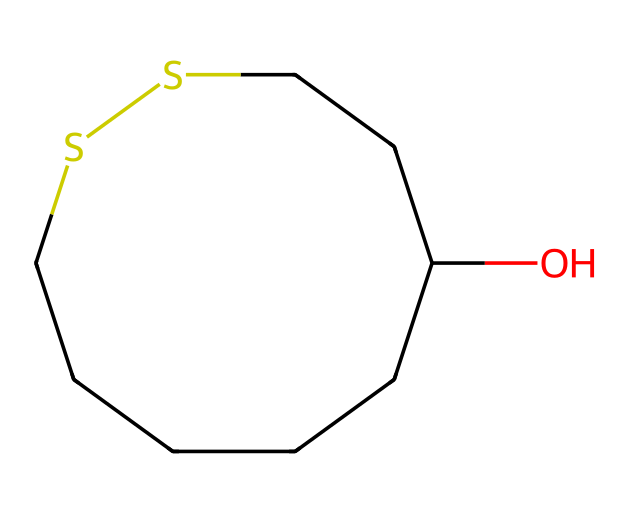How many carbon atoms are present in alpha-lipoic acid? By examining the SMILES structure, we can count the number of 'C' characters, representing carbon atoms. In this structure, there are six 'C' characters, indicating six carbon atoms.
Answer: six What type of functional group is represented by the "OC" portion of the SMILES? The "OC" indicates a hydroxy (alcohol) group, where "O" represents the oxygen atom and "C" is connected to it. This suggests the presence of an alcohol functional group in the compound.
Answer: hydroxy How many sulfur atoms are in the structure? The presence of 'S' in the SMILES indicates sulfur atoms. By counting the 'S' characters in the structure, we find there are two 'S' characters, meaning there are two sulfur atoms.
Answer: two Is alpha-lipoic acid a cyclic compound? The presence of "S1" in the SMILES indicates that there is a ring structure involving the sulfur atoms, which confirms that alpha-lipoic acid is a cyclic compound.
Answer: yes What is the total number of bonds originating from the central carbon atom in the longest chain? In the longest chain of this representation, the central carbon atom typically connects to two carbon atoms in the chain and a hydroxyl group, resulting in four bonds (considering connections to other atoms).
Answer: four What distinguishes alpha-lipoic acid as an antioxidant? The presence of both hydroxy and thiol (sulfur-containing) groups allows it to effectively scavenge free radicals, which gives it antioxidant properties.
Answer: hydroxy and thiol groups 